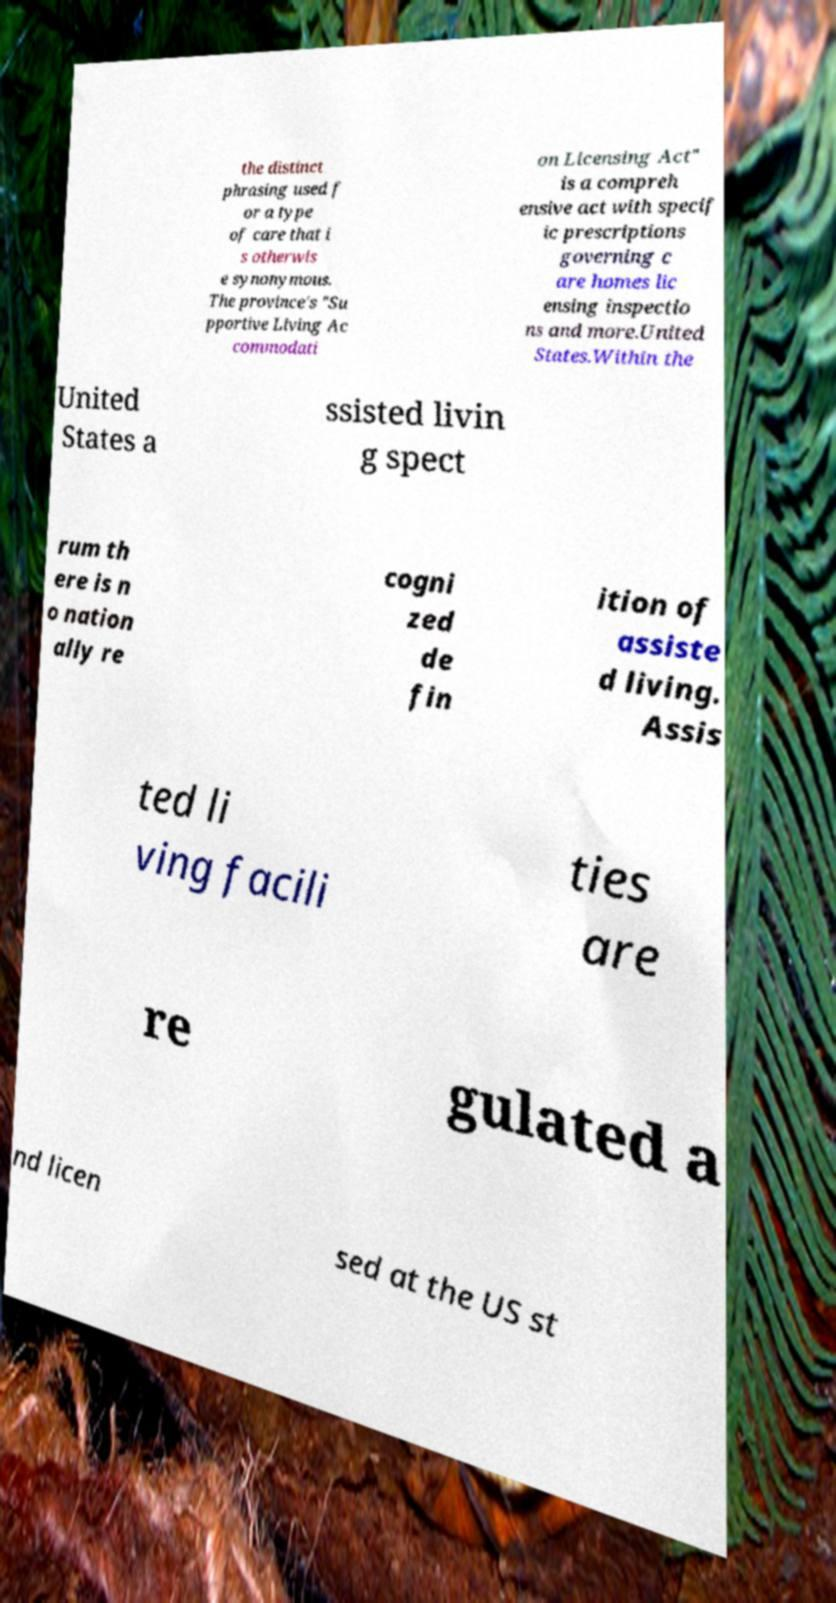I need the written content from this picture converted into text. Can you do that? the distinct phrasing used f or a type of care that i s otherwis e synonymous. The province's "Su pportive Living Ac commodati on Licensing Act" is a compreh ensive act with specif ic prescriptions governing c are homes lic ensing inspectio ns and more.United States.Within the United States a ssisted livin g spect rum th ere is n o nation ally re cogni zed de fin ition of assiste d living. Assis ted li ving facili ties are re gulated a nd licen sed at the US st 